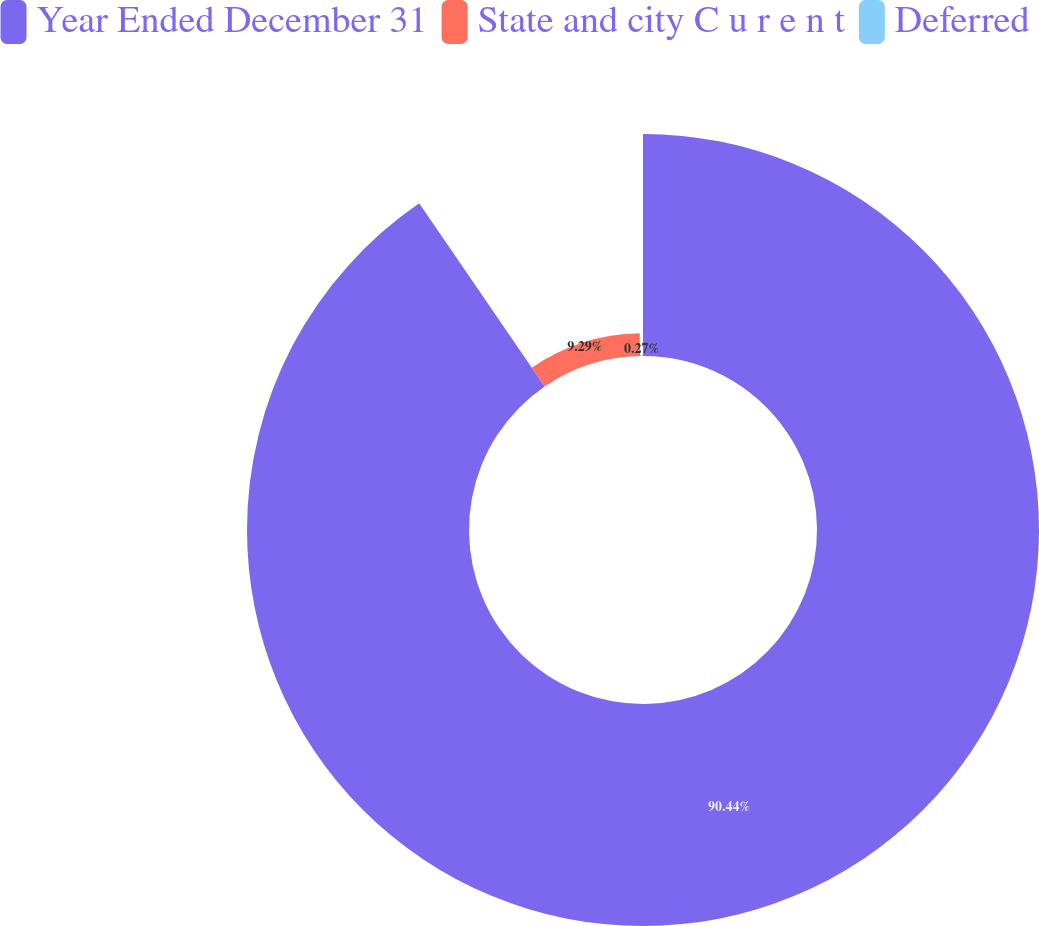<chart> <loc_0><loc_0><loc_500><loc_500><pie_chart><fcel>Year Ended December 31<fcel>State and city C u r e n t<fcel>Deferred<nl><fcel>90.44%<fcel>9.29%<fcel>0.27%<nl></chart> 